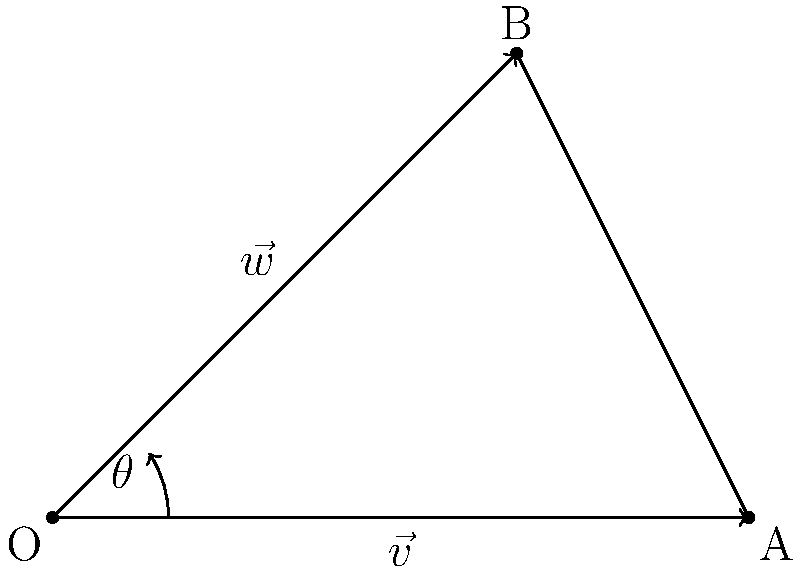In a blockchain security system, two cryptographic signatures are represented by vectors $\vec{v} = (3, 0)$ and $\vec{w} = (2, 2)$. What is the angle $\theta$ between these two vectors, rounded to the nearest degree? To find the angle between two vectors, we can use the dot product formula:

$$\cos \theta = \frac{\vec{v} \cdot \vec{w}}{|\vec{v}| |\vec{w}|}$$

Step 1: Calculate the dot product $\vec{v} \cdot \vec{w}$
$$\vec{v} \cdot \vec{w} = (3)(2) + (0)(2) = 6$$

Step 2: Calculate the magnitudes of the vectors
$$|\vec{v}| = \sqrt{3^2 + 0^2} = 3$$
$$|\vec{w}| = \sqrt{2^2 + 2^2} = 2\sqrt{2}$$

Step 3: Substitute into the formula
$$\cos \theta = \frac{6}{3(2\sqrt{2})} = \frac{\sqrt{2}}{2}$$

Step 4: Take the inverse cosine (arccos) of both sides
$$\theta = \arccos(\frac{\sqrt{2}}{2})$$

Step 5: Convert to degrees and round to the nearest degree
$$\theta \approx 45^\circ$$
Answer: 45° 